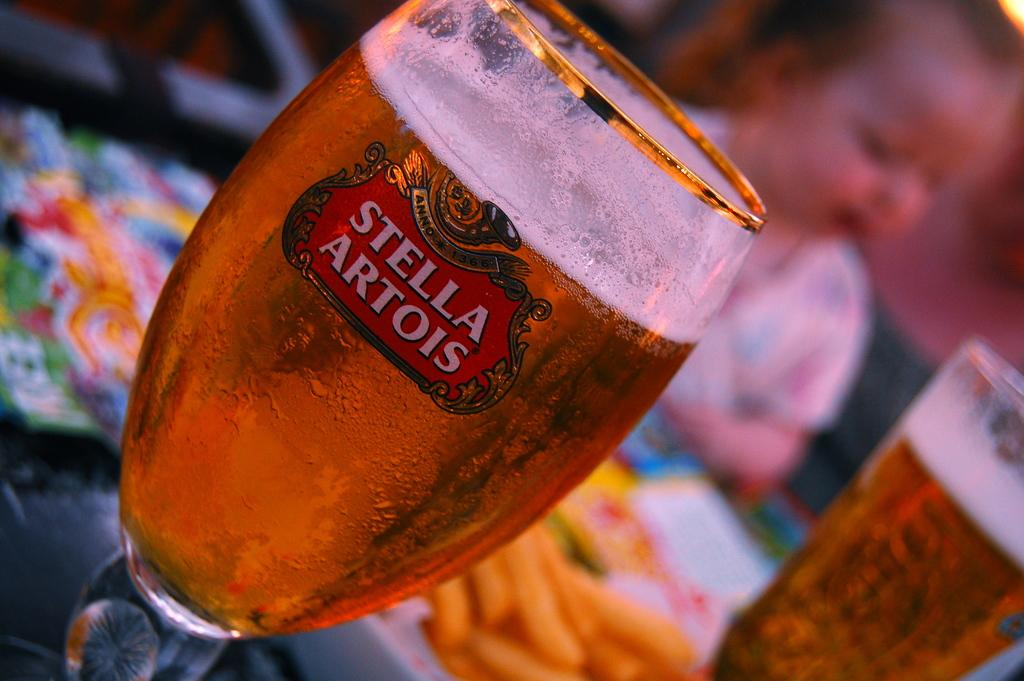<image>
Create a compact narrative representing the image presented. A close up image of a glass of Stella Artois beer. 